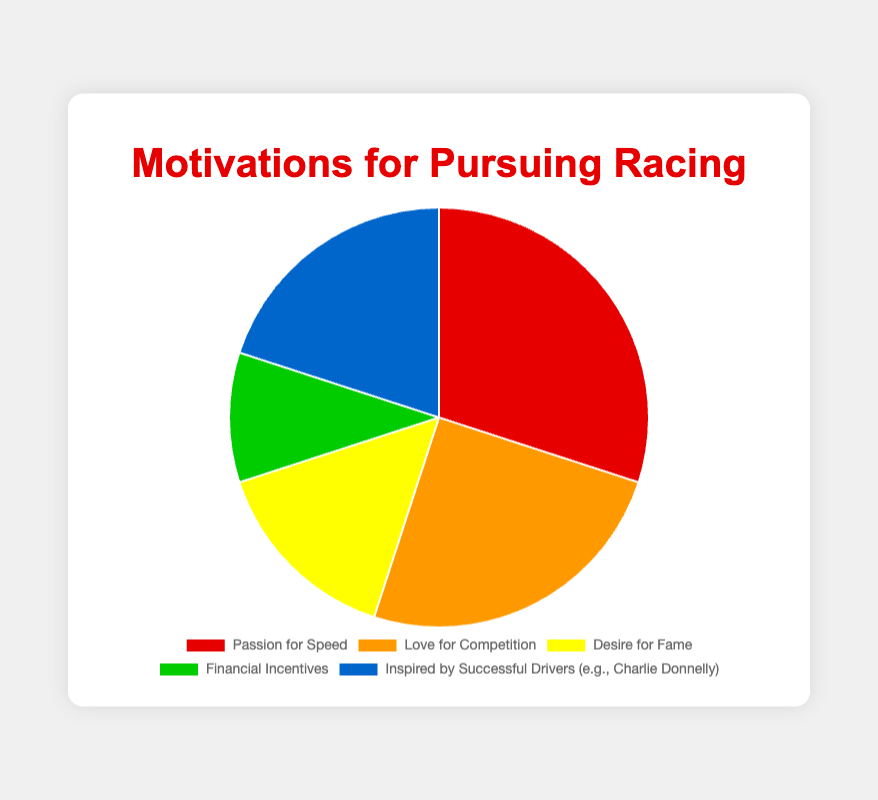what motivation has the highest percentage? The figure shows that the segment labeled "Passion for Speed" has the largest portion of the pie chart, which corresponds to 30%.
Answer: Passion for Speed which is more popular: love for competition or desire for fame? By comparing the two segments, "Love for Competition" shows 25% whereas "Desire for Fame" indicates 15%, making Love for Competition more popular.
Answer: Love for Competition what is the sum of percentages for financial incentives and inspired by successful drivers? Adding the percentages of Financial Incentives (10%) and Inspired by Successful Drivers (20%) results in a total of 30%.
Answer: 30% which motivation category is the least popular? The pie chart shows that "Financial Incentives" has the smallest segment, corresponding to 10%.
Answer: Financial Incentives how does the percentage of inspired by successful drivers compare to love for competition? "Inspired by Successful Drivers" has 20%, which is less than "Love for Competition" at 25%.
Answer: Less what is the combined percentage for passion for speed and love for competition? Adding Passion for Speed (30%) and Love for Competition (25%) results in a combined percentage of 55%.
Answer: 55% if desire for fame and financial incentives are combined, how does their total compare to passion for speed? The combined total of Desire for Fame (15%) and Financial Incentives (10%) is 25%, which is less than Passion for Speed's 30%.
Answer: Less which segment of the pie chart is shown in red? The segment in red corresponds to "Passion for Speed".
Answer: Passion for Speed what proportion of the chart does the love for competition and financial incentives together take up? Adding Love for Competition (25%) and Financial Incentives (10%) results in 35%, which they collectively take up on the chart.
Answer: 35% if love for competition increased by 5%, what would be its new percentage and how would it compare to passion for speed? Increasing Love for Competition by 5% changes it from 25% to 30%, making it equal to the percentage for Passion for Speed.
Answer: 30%, Equal 